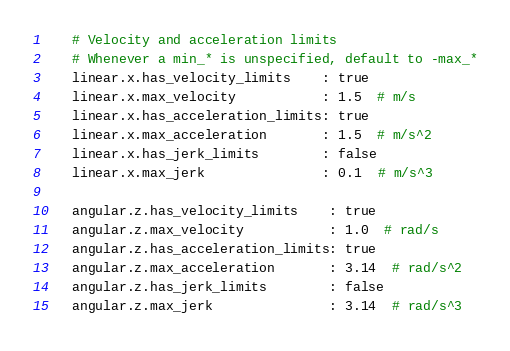Convert code to text. <code><loc_0><loc_0><loc_500><loc_500><_YAML_>    # Velocity and acceleration limits
    # Whenever a min_* is unspecified, default to -max_*
    linear.x.has_velocity_limits    : true
    linear.x.max_velocity           : 1.5  # m/s
    linear.x.has_acceleration_limits: true
    linear.x.max_acceleration       : 1.5  # m/s^2
    linear.x.has_jerk_limits        : false
    linear.x.max_jerk               : 0.1  # m/s^3

    angular.z.has_velocity_limits    : true
    angular.z.max_velocity           : 1.0  # rad/s
    angular.z.has_acceleration_limits: true
    angular.z.max_acceleration       : 3.14  # rad/s^2
    angular.z.has_jerk_limits        : false
    angular.z.max_jerk               : 3.14  # rad/s^3
</code> 